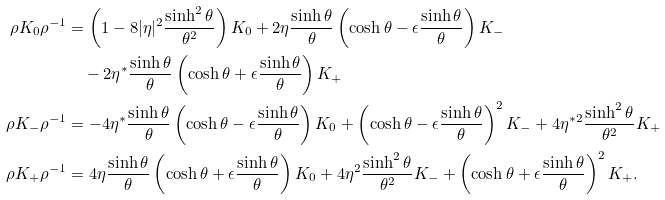Convert formula to latex. <formula><loc_0><loc_0><loc_500><loc_500>\rho K _ { 0 } \rho ^ { - 1 } & = \left ( 1 - 8 | \eta | ^ { 2 } \frac { \sinh ^ { 2 } \theta } { \theta ^ { 2 } } \right ) K _ { 0 } + 2 \eta \frac { \sinh \theta } { \theta } \left ( \cosh \theta - \epsilon \frac { \sinh \theta } { \theta } \right ) K _ { - } \\ & \quad - 2 \eta ^ { * } \frac { \sinh \theta } { \theta } \left ( \cosh \theta + \epsilon \frac { \sinh \theta } { \theta } \right ) K _ { + } \\ \rho K _ { - } \rho ^ { - 1 } & = - 4 \eta ^ { * } \frac { \sinh \theta } { \theta } \left ( \cosh \theta - \epsilon \frac { \sinh \theta } { \theta } \right ) K _ { 0 } + \left ( \cosh \theta - \epsilon \frac { \sinh \theta } { \theta } \right ) ^ { 2 } K _ { - } + 4 \eta ^ { * 2 } \frac { \sinh ^ { 2 } \theta } { \theta ^ { 2 } } K _ { + } \\ \rho K _ { + } \rho ^ { - 1 } & = 4 \eta \frac { \sinh \theta } { \theta } \left ( \cosh \theta + \epsilon \frac { \sinh \theta } { \theta } \right ) K _ { 0 } + 4 \eta ^ { 2 } \frac { \sinh ^ { 2 } \theta } { \theta ^ { 2 } } K _ { - } + \left ( \cosh \theta + \epsilon \frac { \sinh \theta } { \theta } \right ) ^ { 2 } K _ { + } .</formula> 